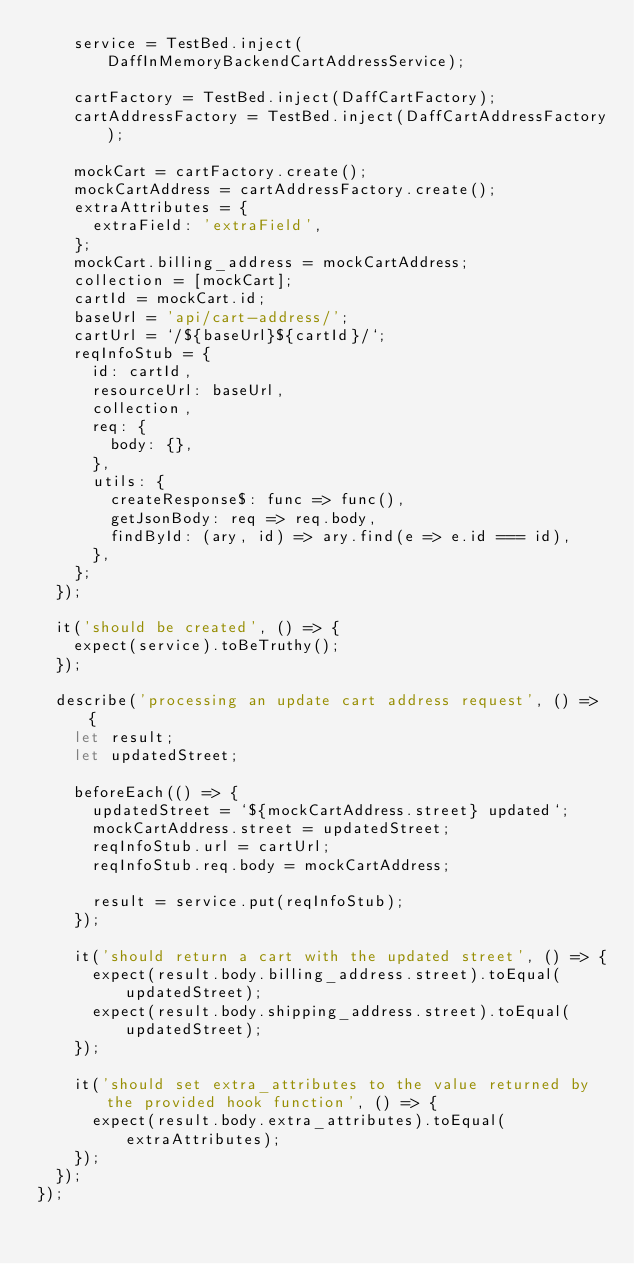<code> <loc_0><loc_0><loc_500><loc_500><_TypeScript_>    service = TestBed.inject(DaffInMemoryBackendCartAddressService);

    cartFactory = TestBed.inject(DaffCartFactory);
    cartAddressFactory = TestBed.inject(DaffCartAddressFactory);

    mockCart = cartFactory.create();
    mockCartAddress = cartAddressFactory.create();
    extraAttributes = {
      extraField: 'extraField',
    };
    mockCart.billing_address = mockCartAddress;
    collection = [mockCart];
    cartId = mockCart.id;
    baseUrl = 'api/cart-address/';
    cartUrl = `/${baseUrl}${cartId}/`;
    reqInfoStub = {
      id: cartId,
      resourceUrl: baseUrl,
      collection,
      req: {
        body: {},
      },
      utils: {
        createResponse$: func => func(),
        getJsonBody: req => req.body,
        findById: (ary, id) => ary.find(e => e.id === id),
      },
    };
  });

  it('should be created', () => {
    expect(service).toBeTruthy();
  });

  describe('processing an update cart address request', () => {
    let result;
    let updatedStreet;

    beforeEach(() => {
      updatedStreet = `${mockCartAddress.street} updated`;
      mockCartAddress.street = updatedStreet;
      reqInfoStub.url = cartUrl;
      reqInfoStub.req.body = mockCartAddress;

      result = service.put(reqInfoStub);
    });

    it('should return a cart with the updated street', () => {
      expect(result.body.billing_address.street).toEqual(updatedStreet);
      expect(result.body.shipping_address.street).toEqual(updatedStreet);
    });

    it('should set extra_attributes to the value returned by the provided hook function', () => {
      expect(result.body.extra_attributes).toEqual(extraAttributes);
    });
  });
});
</code> 